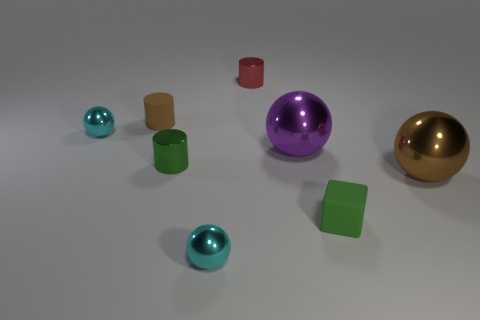Add 1 green cubes. How many objects exist? 9 Subtract all cylinders. How many objects are left? 5 Add 7 green blocks. How many green blocks exist? 8 Subtract 0 yellow blocks. How many objects are left? 8 Subtract all small brown things. Subtract all big cyan metallic things. How many objects are left? 7 Add 4 brown matte objects. How many brown matte objects are left? 5 